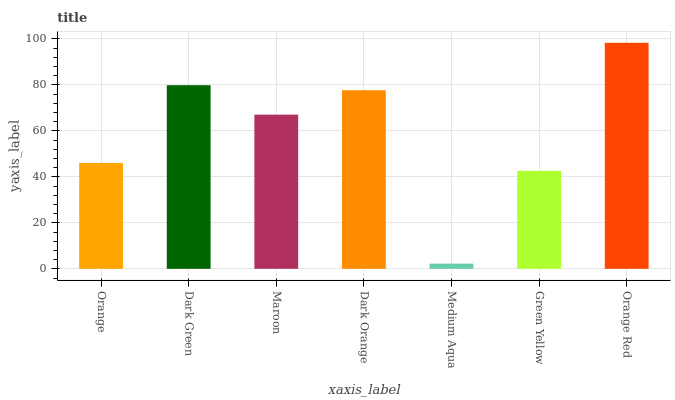Is Orange Red the maximum?
Answer yes or no. Yes. Is Dark Green the minimum?
Answer yes or no. No. Is Dark Green the maximum?
Answer yes or no. No. Is Dark Green greater than Orange?
Answer yes or no. Yes. Is Orange less than Dark Green?
Answer yes or no. Yes. Is Orange greater than Dark Green?
Answer yes or no. No. Is Dark Green less than Orange?
Answer yes or no. No. Is Maroon the high median?
Answer yes or no. Yes. Is Maroon the low median?
Answer yes or no. Yes. Is Orange Red the high median?
Answer yes or no. No. Is Dark Green the low median?
Answer yes or no. No. 